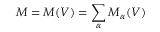<formula> <loc_0><loc_0><loc_500><loc_500>M = M ( V ) = \sum _ { \alpha } M _ { \alpha } ( V )</formula> 